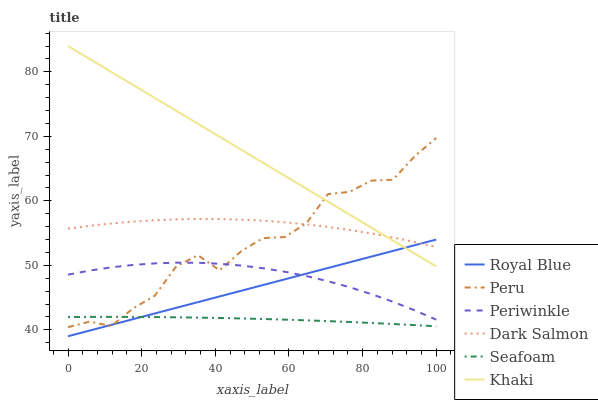Does Dark Salmon have the minimum area under the curve?
Answer yes or no. No. Does Dark Salmon have the maximum area under the curve?
Answer yes or no. No. Is Dark Salmon the smoothest?
Answer yes or no. No. Is Dark Salmon the roughest?
Answer yes or no. No. Does Seafoam have the lowest value?
Answer yes or no. No. Does Dark Salmon have the highest value?
Answer yes or no. No. Is Periwinkle less than Khaki?
Answer yes or no. Yes. Is Khaki greater than Seafoam?
Answer yes or no. Yes. Does Periwinkle intersect Khaki?
Answer yes or no. No. 